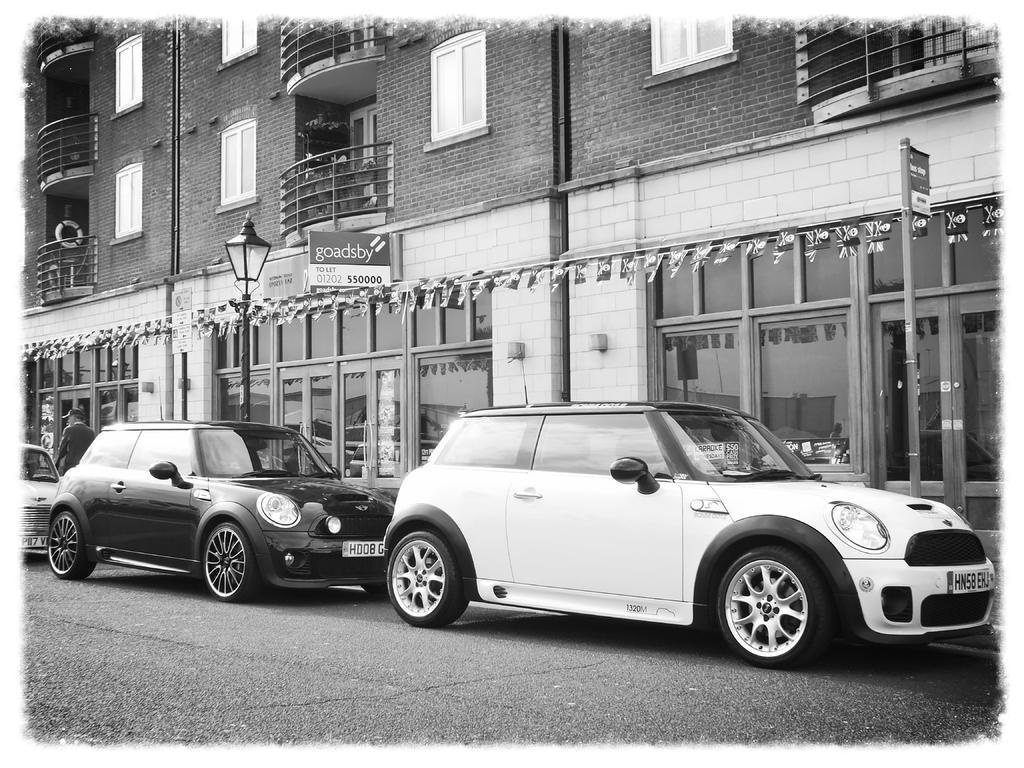How would you summarize this image in a sentence or two? This image is a black and white image. This image is taken outdoors. At the bottom of the image there is a road. In the background there is a building with walls, windows, railings, balconies and door. There is a board with a text on it. There is a street light. In the middle of the image three cars are parked on the road and a man is walking on the sidewalk. 